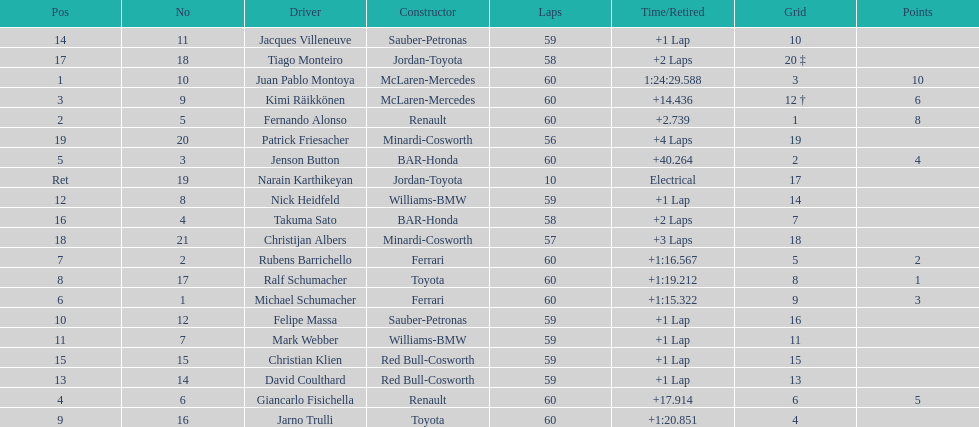What is the number of toyota's on the list? 4. 